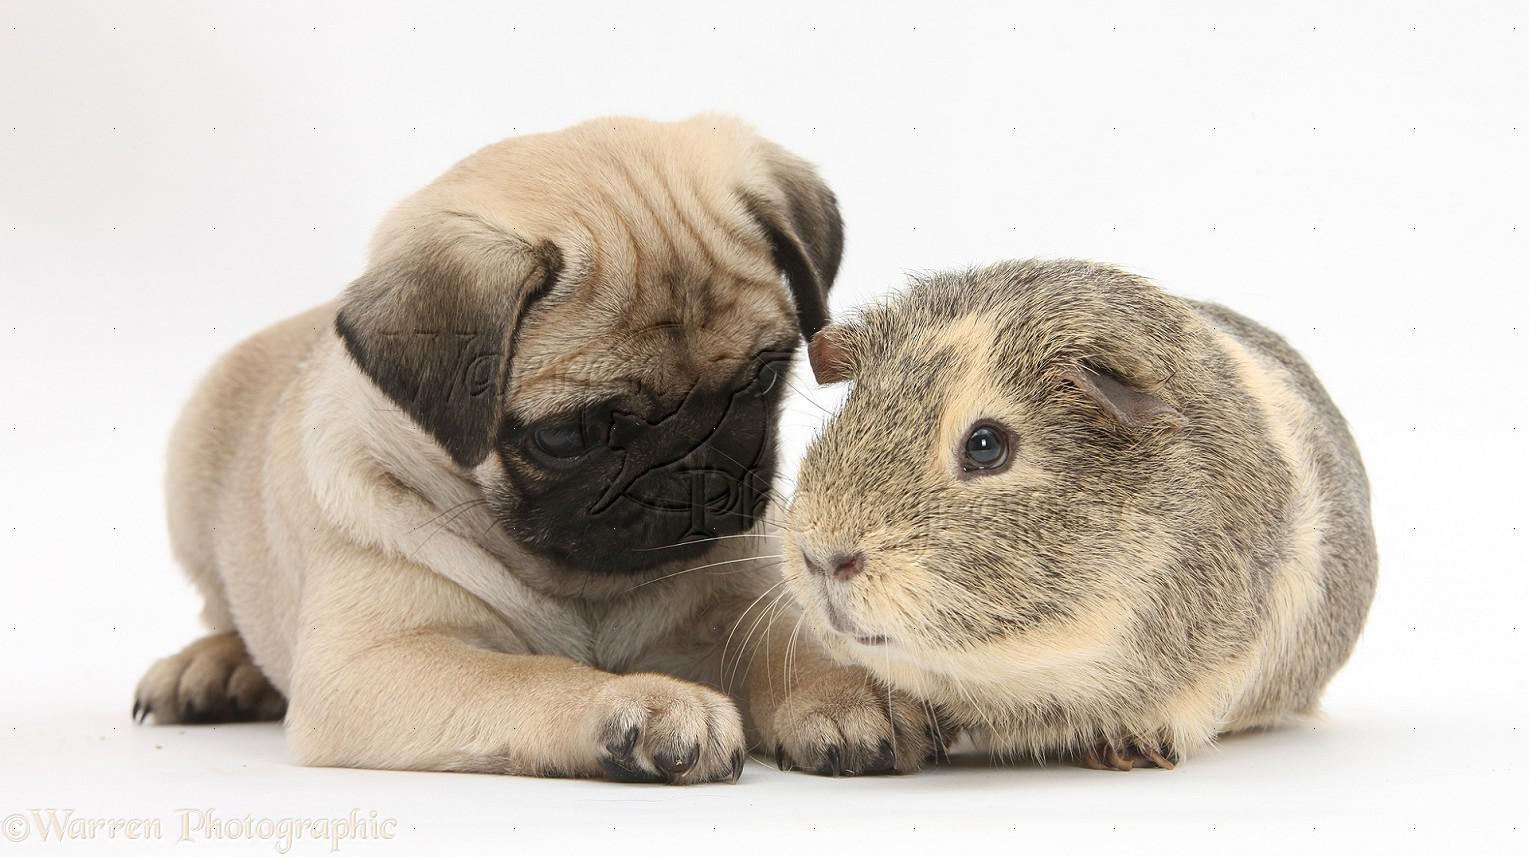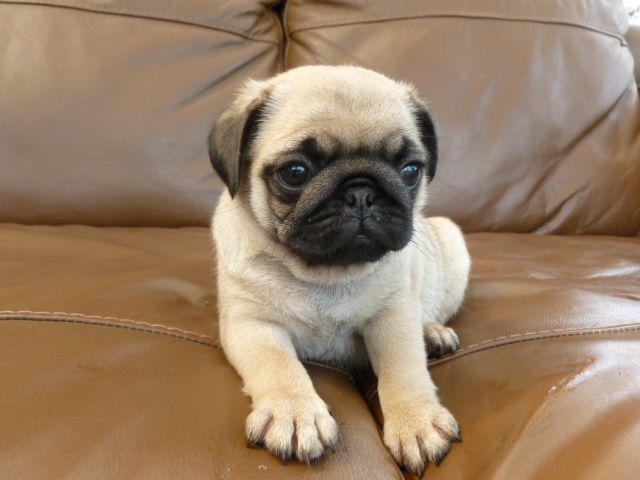The first image is the image on the left, the second image is the image on the right. Analyze the images presented: Is the assertion "An image shows just one pug dog on a leather-type seat." valid? Answer yes or no. Yes. The first image is the image on the left, the second image is the image on the right. Given the left and right images, does the statement "A dog is sitting on a shiny seat in the image on the right." hold true? Answer yes or no. Yes. 